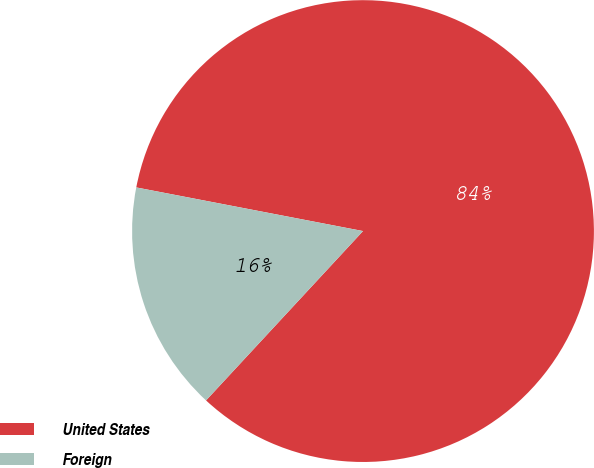Convert chart. <chart><loc_0><loc_0><loc_500><loc_500><pie_chart><fcel>United States<fcel>Foreign<nl><fcel>83.87%<fcel>16.13%<nl></chart> 